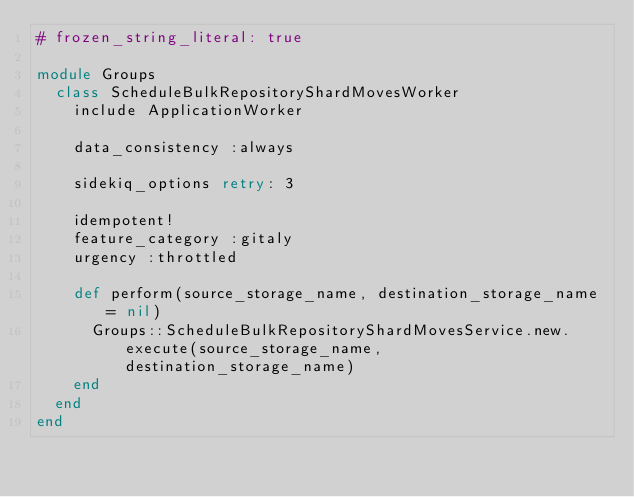<code> <loc_0><loc_0><loc_500><loc_500><_Ruby_># frozen_string_literal: true

module Groups
  class ScheduleBulkRepositoryShardMovesWorker
    include ApplicationWorker

    data_consistency :always

    sidekiq_options retry: 3

    idempotent!
    feature_category :gitaly
    urgency :throttled

    def perform(source_storage_name, destination_storage_name = nil)
      Groups::ScheduleBulkRepositoryShardMovesService.new.execute(source_storage_name, destination_storage_name)
    end
  end
end
</code> 